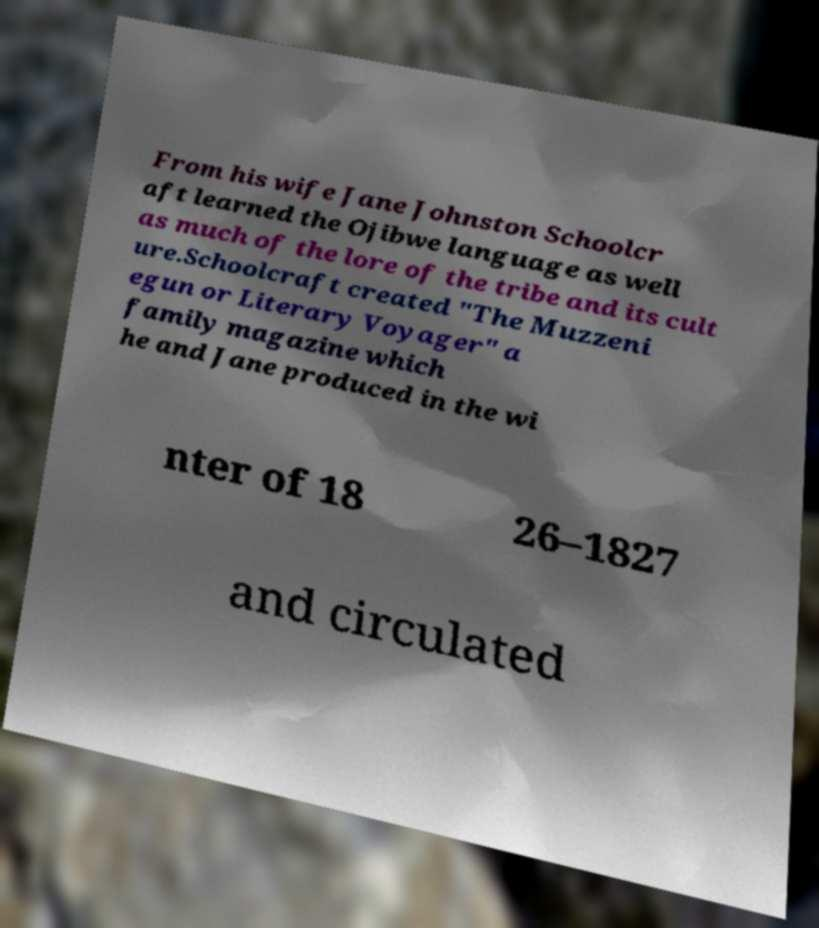Please identify and transcribe the text found in this image. From his wife Jane Johnston Schoolcr aft learned the Ojibwe language as well as much of the lore of the tribe and its cult ure.Schoolcraft created "The Muzzeni egun or Literary Voyager" a family magazine which he and Jane produced in the wi nter of 18 26–1827 and circulated 